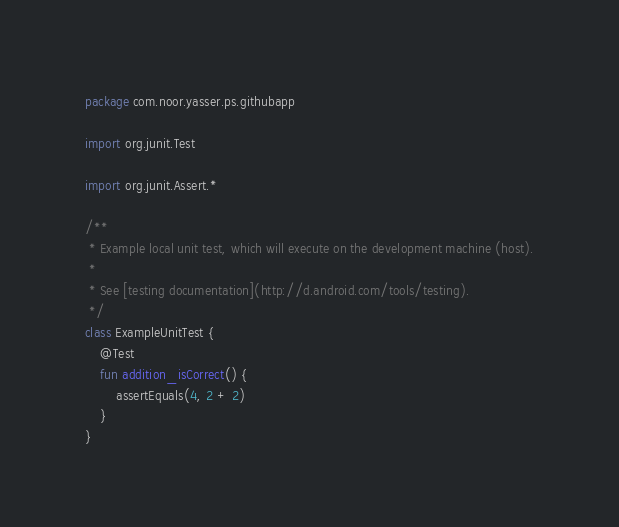Convert code to text. <code><loc_0><loc_0><loc_500><loc_500><_Kotlin_>package com.noor.yasser.ps.githubapp

import org.junit.Test

import org.junit.Assert.*

/**
 * Example local unit test, which will execute on the development machine (host).
 *
 * See [testing documentation](http://d.android.com/tools/testing).
 */
class ExampleUnitTest {
    @Test
    fun addition_isCorrect() {
        assertEquals(4, 2 + 2)
    }
}</code> 